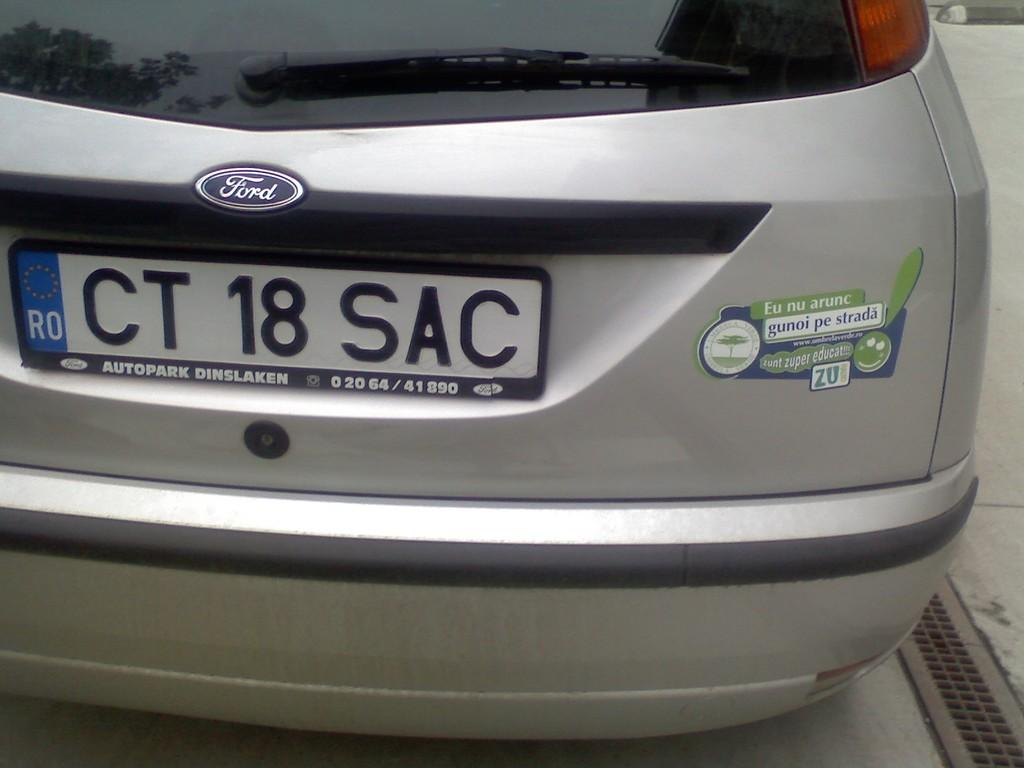<image>
Present a compact description of the photo's key features. a license plate that had CT on the back 